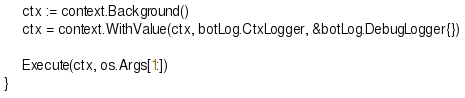<code> <loc_0><loc_0><loc_500><loc_500><_Go_>	ctx := context.Background()
	ctx = context.WithValue(ctx, botLog.CtxLogger, &botLog.DebugLogger{})

	Execute(ctx, os.Args[1:])
}
</code> 